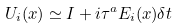<formula> <loc_0><loc_0><loc_500><loc_500>U _ { i } ( x ) \simeq I + i \tau ^ { a } E _ { i } ( x ) \delta t</formula> 